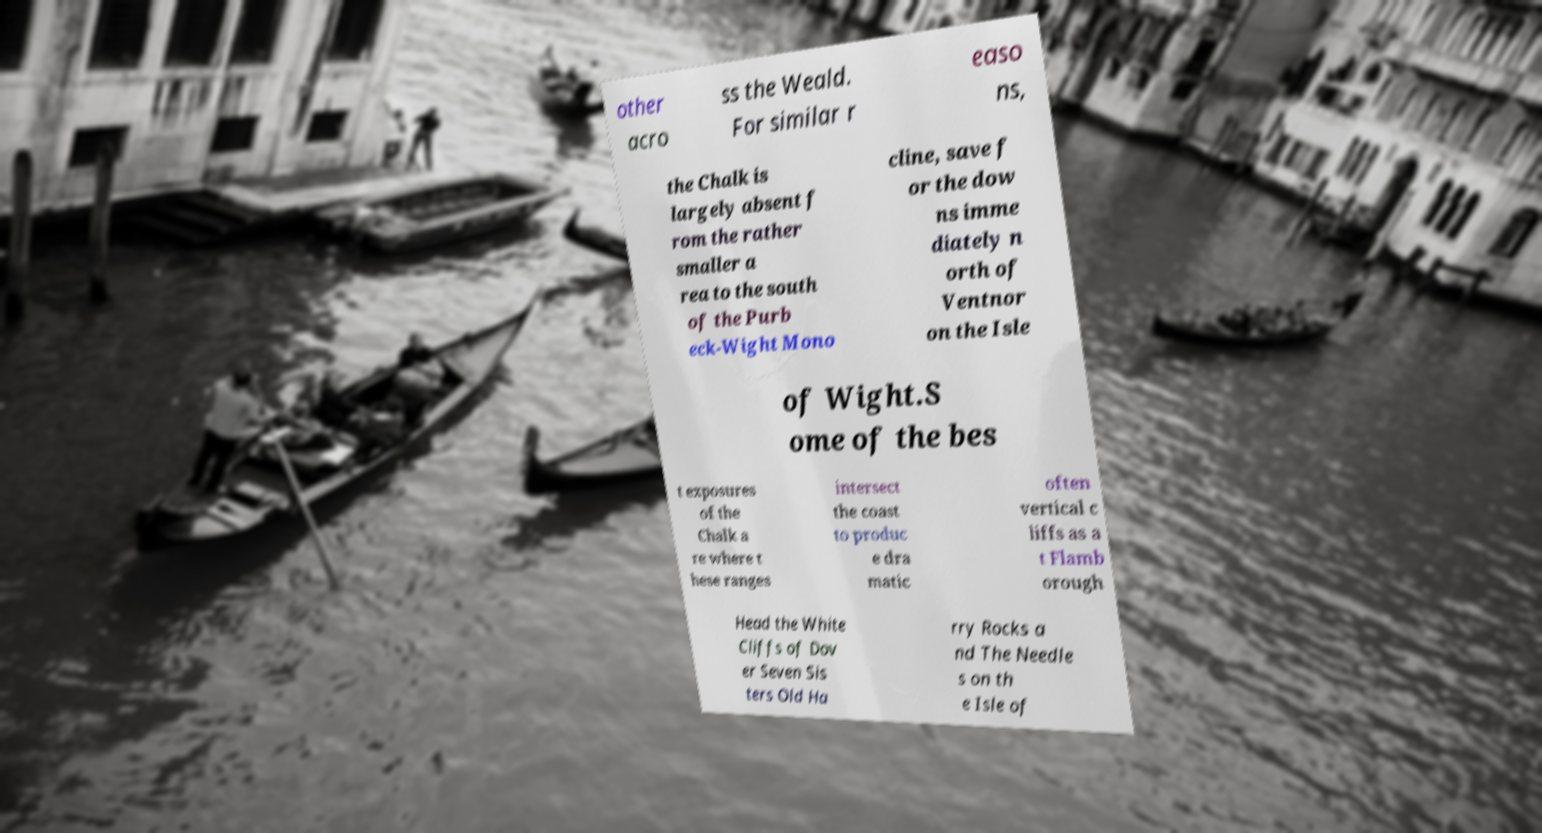Can you read and provide the text displayed in the image?This photo seems to have some interesting text. Can you extract and type it out for me? other acro ss the Weald. For similar r easo ns, the Chalk is largely absent f rom the rather smaller a rea to the south of the Purb eck-Wight Mono cline, save f or the dow ns imme diately n orth of Ventnor on the Isle of Wight.S ome of the bes t exposures of the Chalk a re where t hese ranges intersect the coast to produc e dra matic often vertical c liffs as a t Flamb orough Head the White Cliffs of Dov er Seven Sis ters Old Ha rry Rocks a nd The Needle s on th e Isle of 